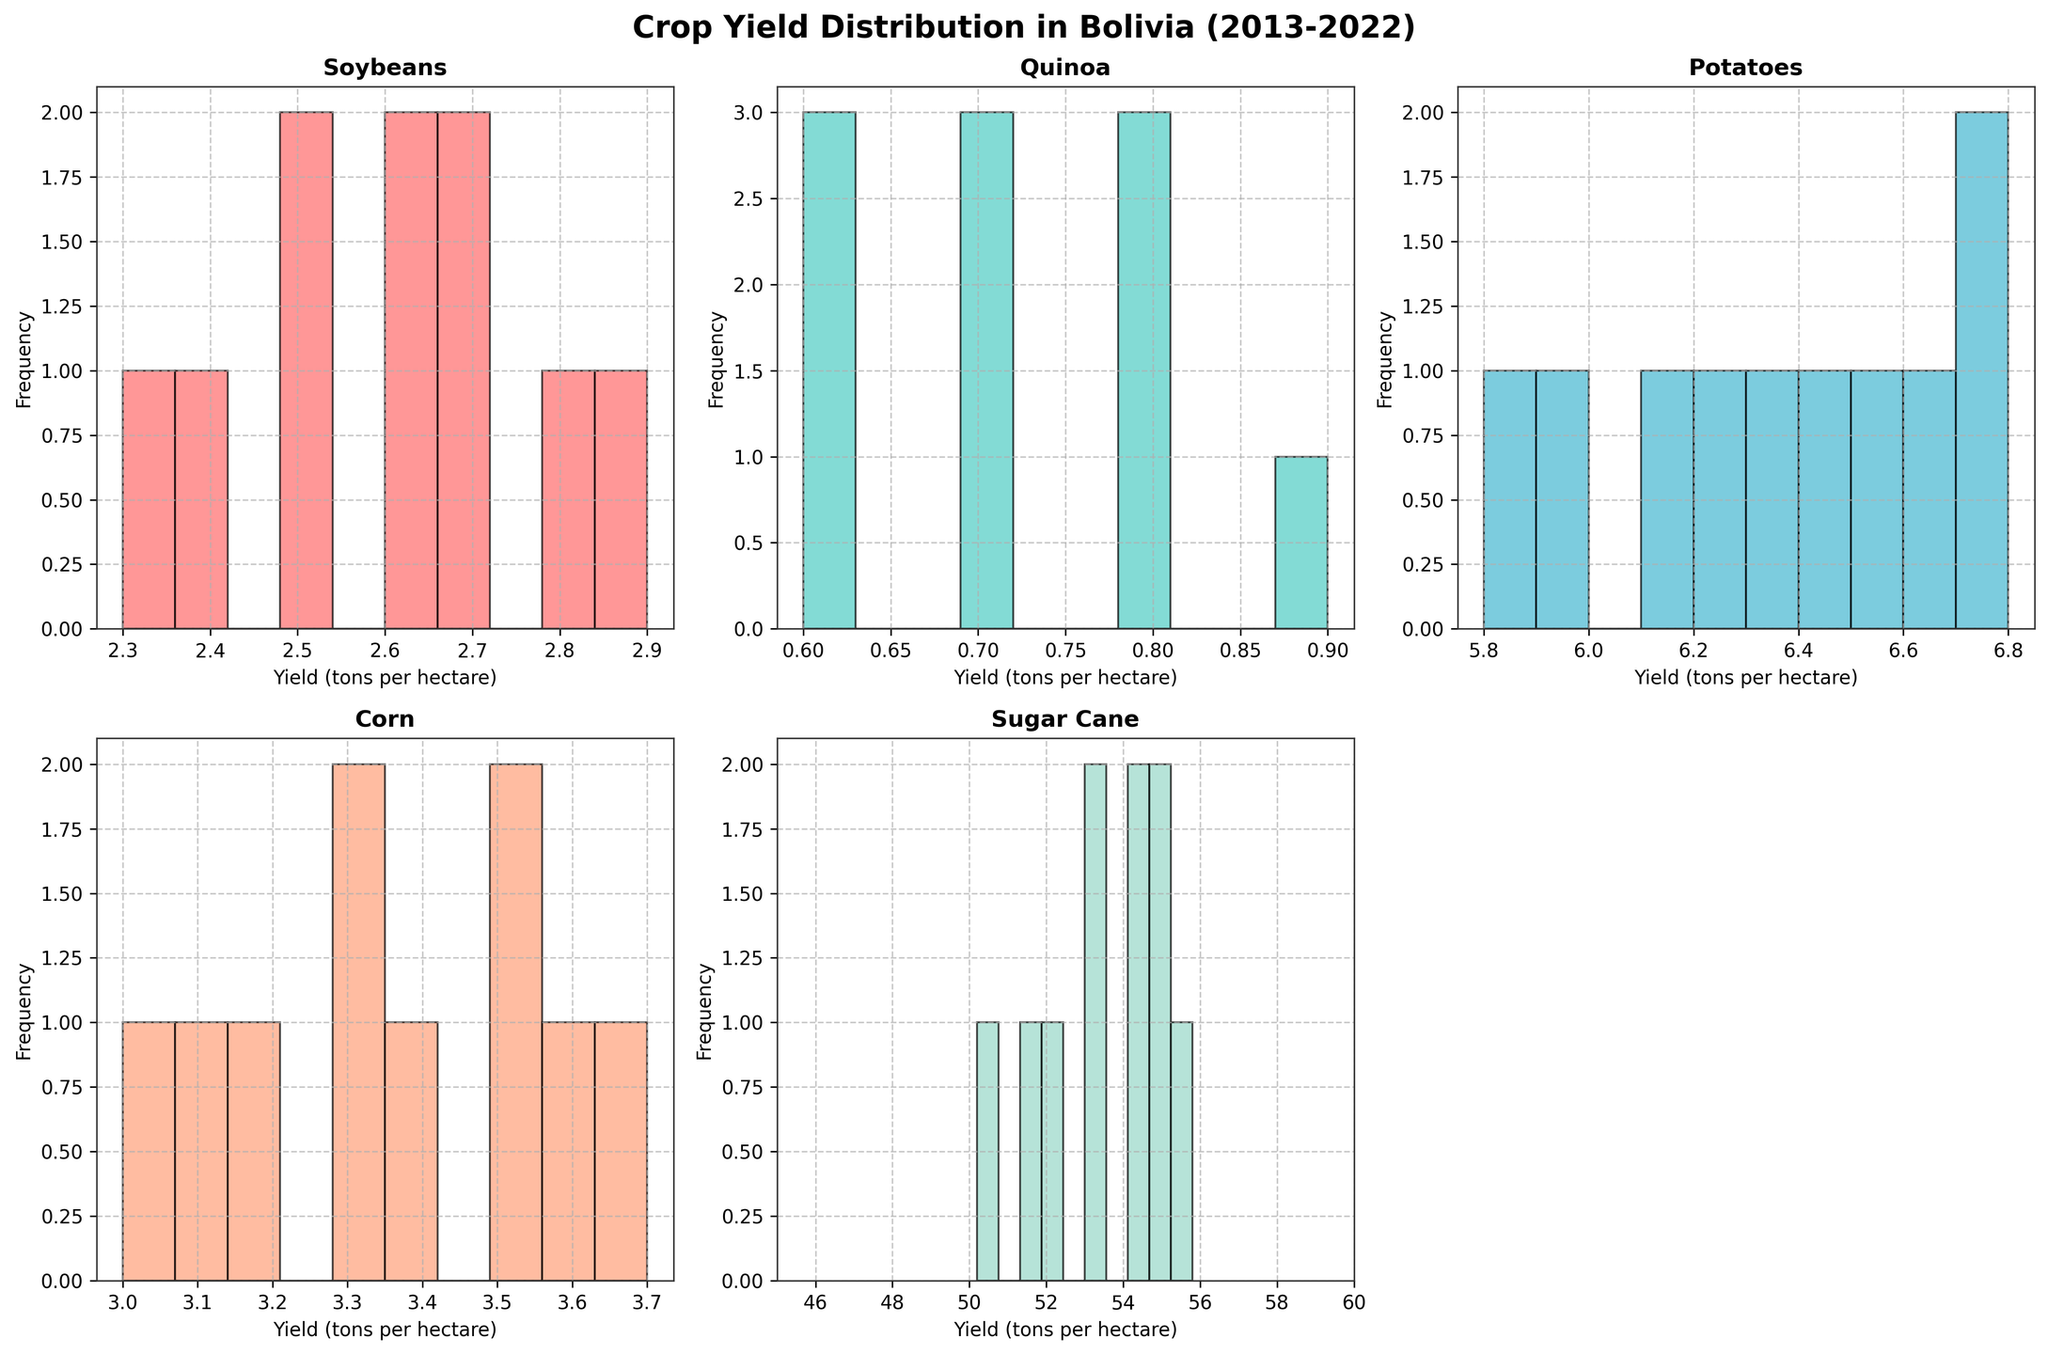what's the title of the figure? The title of the figure is found at the top-center of the plot. It describes the content represented in all the subplots combined. By looking at the top of the figure, you can see the title that summarizes the data presented in the histograms.
Answer: Crop Yield Distribution in Bolivia (2013-2022) how many histograms are there in the figure? Count each individual histogram plot within the entire figure. The figure contains subplots of histograms for different crops.
Answer: 5 which crop has the most spread in yield (tons per hectare)? Look at the width of the histograms. The crop with the largest spread will have a wider range on the x-axis, indicating more variation in yield. The histogram for "Sugar Cane" has the widest spread.
Answer: Sugar Cane is the median yield for Potatoes higher or lower than the median yield for Corn? Observe the central tendency of the histogram for both Potatoes and Corn. The median for Potatoes (centered around 6.6) is higher than that for Corn (centered around 3.5).
Answer: Higher which crop has the highest frequency in a single bin and what is that frequency? Inspect all histograms and identify the highest bar among all, noting the crop it represents and the frequency value on the y-axis. The Potatoes histogram has a bin with the highest frequency (~3).
Answer: Potatoes, approx. 3 what's the mode of Sugar Cane yield? The mode is the most frequently occurring value in the Sugar Cane histogram. The highest bar for Sugar Cane hovers around the value 55.0.
Answer: About 55.0 which crop shows the lowest yield values consistently over the past decade? Examine the position of the leftmost bars of each histogram, focusing on the crop with yield concentrated at low values. The Quinoa histogram shows consistently low values, mostly around 0.6 - 0.9.
Answer: Quinoa compare the yield range of Soybeans and Quinoa. Which crop has a larger range? The yield range is the difference between the max and min values on the x-axis. Compare the range width of the Soybeans and Quinoa histograms. Soybeans range from about 2.3 to 2.9, and Quinoa ranges from about 0.6 to 0.9. Soybeans have a larger range.
Answer: Soybeans 